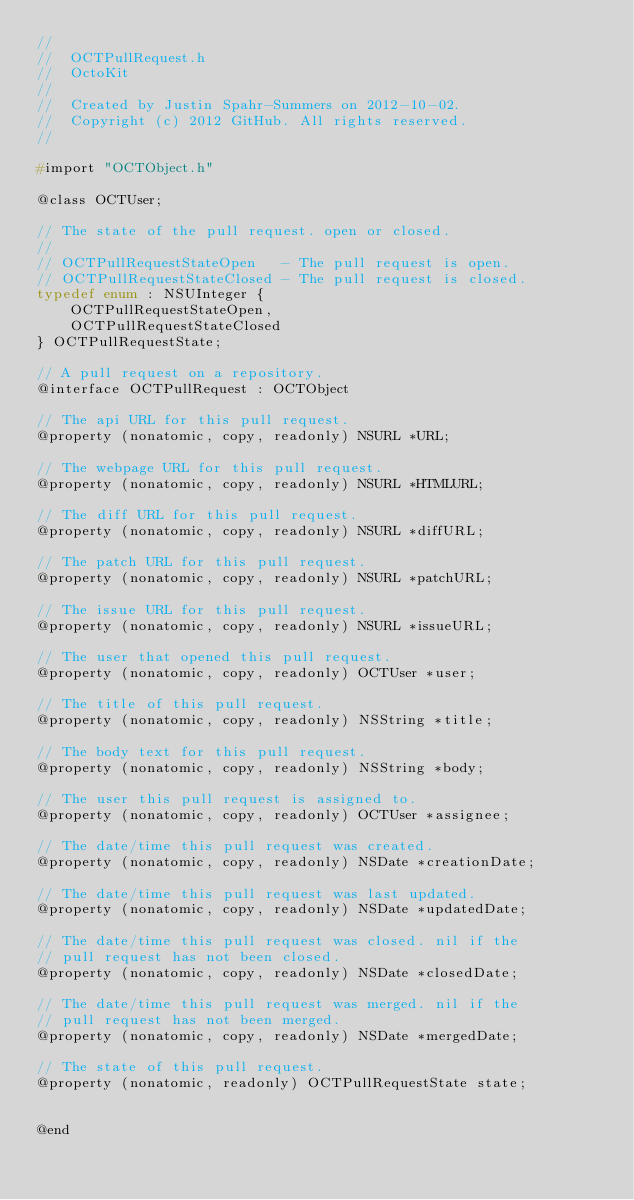Convert code to text. <code><loc_0><loc_0><loc_500><loc_500><_C_>//
//  OCTPullRequest.h
//  OctoKit
//
//  Created by Justin Spahr-Summers on 2012-10-02.
//  Copyright (c) 2012 GitHub. All rights reserved.
//

#import "OCTObject.h"

@class OCTUser;

// The state of the pull request. open or closed.
//
// OCTPullRequestStateOpen   - The pull request is open.
// OCTPullRequestStateClosed - The pull request is closed.
typedef enum : NSUInteger {
    OCTPullRequestStateOpen,
    OCTPullRequestStateClosed
} OCTPullRequestState;

// A pull request on a repository.
@interface OCTPullRequest : OCTObject

// The api URL for this pull request.
@property (nonatomic, copy, readonly) NSURL *URL;

// The webpage URL for this pull request.
@property (nonatomic, copy, readonly) NSURL *HTMLURL;

// The diff URL for this pull request.
@property (nonatomic, copy, readonly) NSURL *diffURL;

// The patch URL for this pull request.
@property (nonatomic, copy, readonly) NSURL *patchURL;

// The issue URL for this pull request.
@property (nonatomic, copy, readonly) NSURL *issueURL;

// The user that opened this pull request.
@property (nonatomic, copy, readonly) OCTUser *user;

// The title of this pull request.
@property (nonatomic, copy, readonly) NSString *title;

// The body text for this pull request.
@property (nonatomic, copy, readonly) NSString *body;

// The user this pull request is assigned to.
@property (nonatomic, copy, readonly) OCTUser *assignee;

// The date/time this pull request was created.
@property (nonatomic, copy, readonly) NSDate *creationDate;

// The date/time this pull request was last updated.
@property (nonatomic, copy, readonly) NSDate *updatedDate;

// The date/time this pull request was closed. nil if the
// pull request has not been closed.
@property (nonatomic, copy, readonly) NSDate *closedDate;

// The date/time this pull request was merged. nil if the
// pull request has not been merged.
@property (nonatomic, copy, readonly) NSDate *mergedDate;

// The state of this pull request.
@property (nonatomic, readonly) OCTPullRequestState state;


@end
</code> 